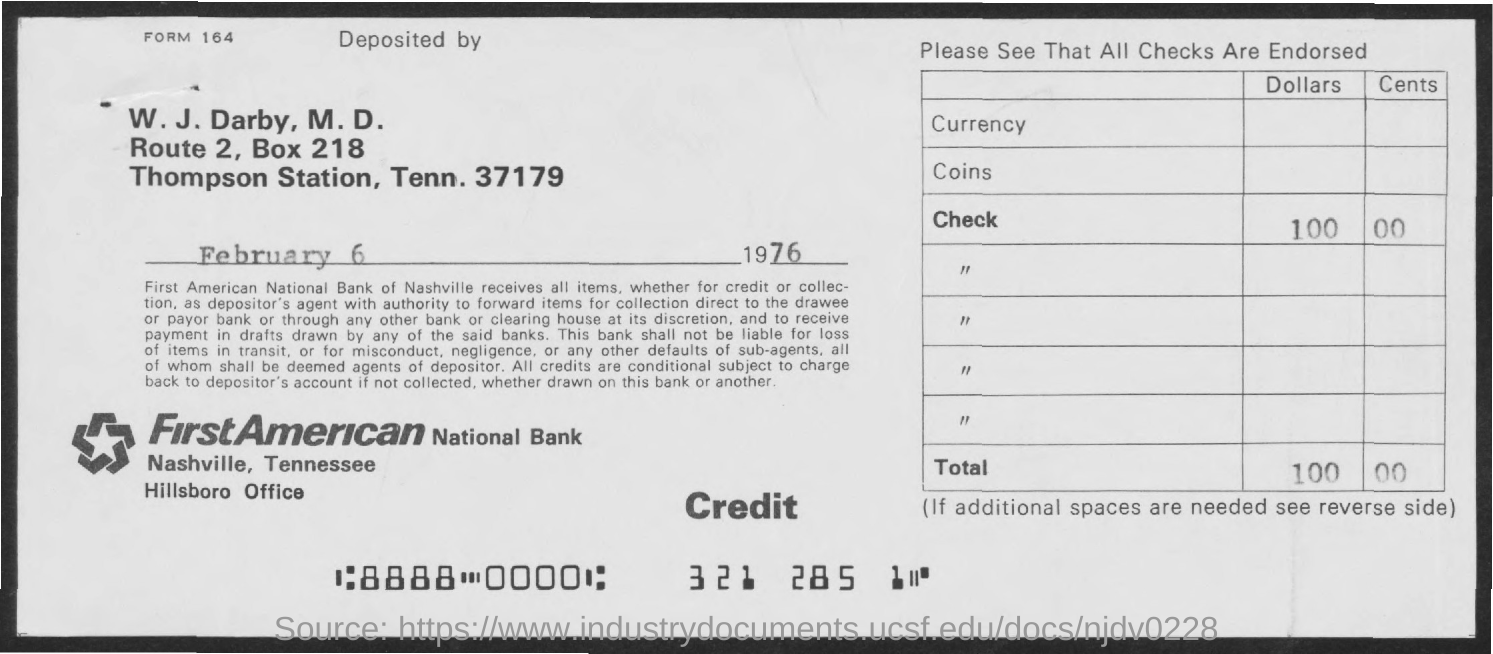Draw attention to some important aspects in this diagram. The BOX Number is 218. 